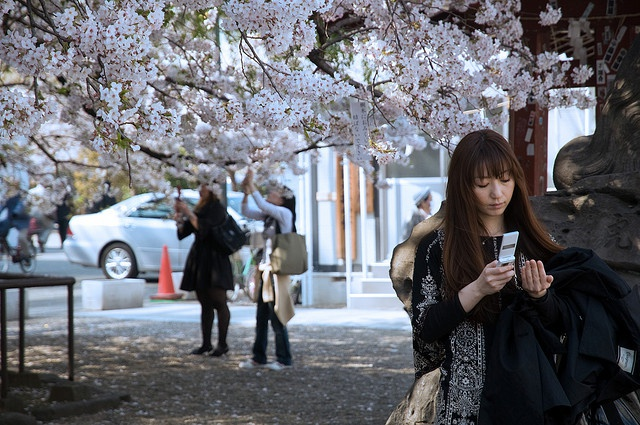Describe the objects in this image and their specific colors. I can see people in black, gray, maroon, and darkgray tones, car in black, white, lightblue, and darkgray tones, people in black, gray, maroon, and darkgray tones, people in black, gray, and darkgray tones, and handbag in black, gray, and darkgray tones in this image. 